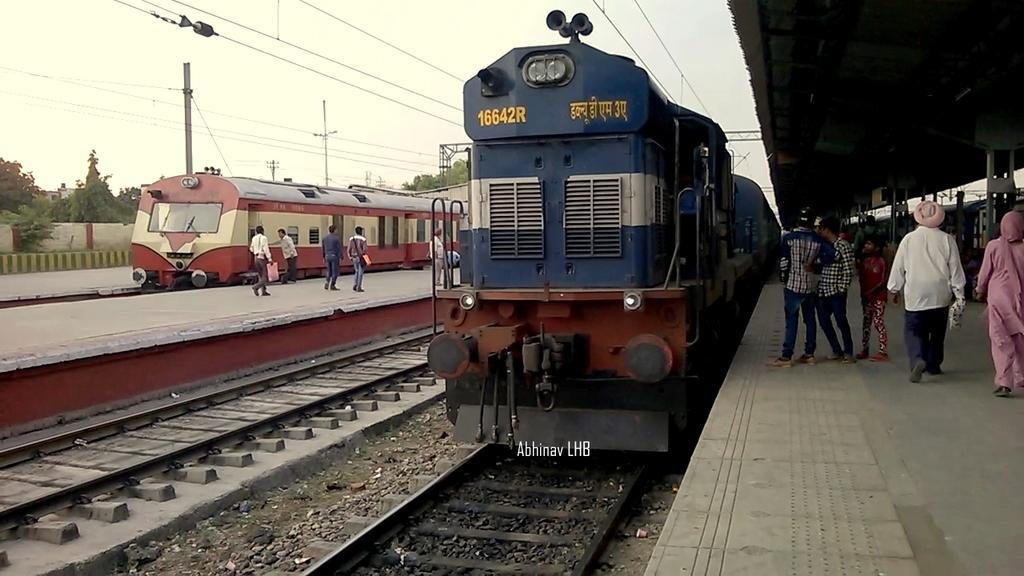In one or two sentences, can you explain what this image depicts? In this image I can see trains and railway track , platform in the middle and I can see the few persons walking on the platform ,on the right side I can see platform and I can see few persons walking and on the left side there are trees and the sky. 